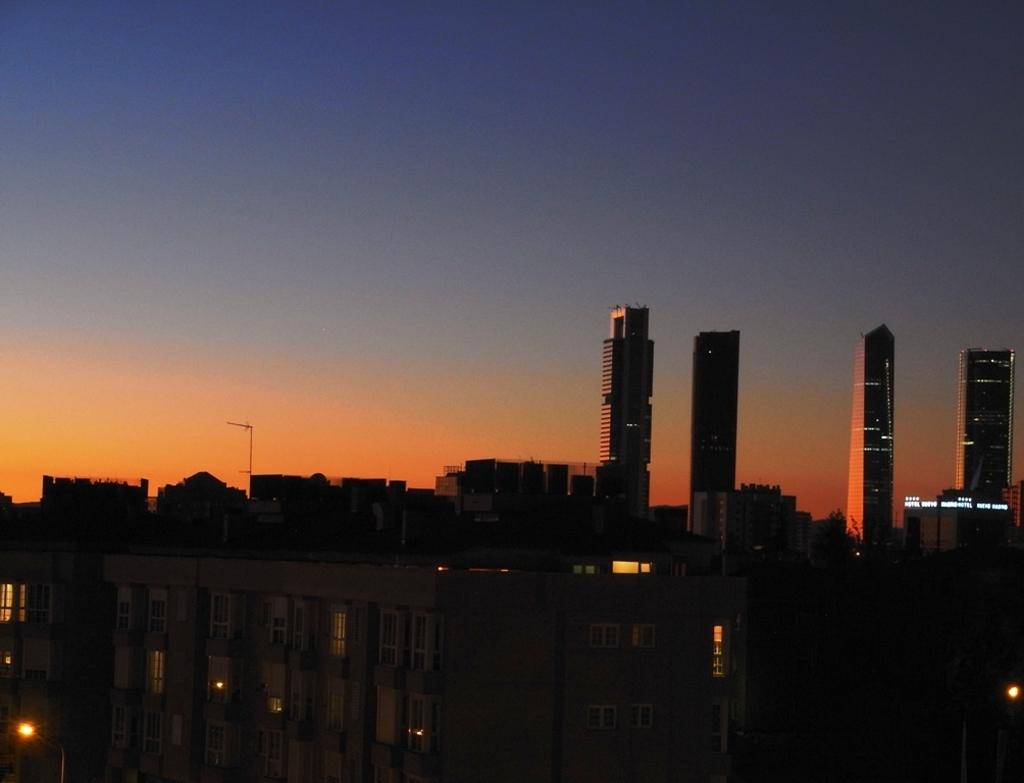In one or two sentences, can you explain what this image depicts? There are few buildings and there are four tower buildings in the background. 